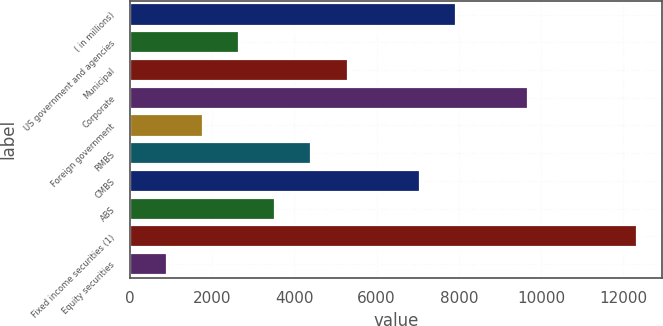<chart> <loc_0><loc_0><loc_500><loc_500><bar_chart><fcel>( in millions)<fcel>US government and agencies<fcel>Municipal<fcel>Corporate<fcel>Foreign government<fcel>RMBS<fcel>CMBS<fcel>ABS<fcel>Fixed income securities (1)<fcel>Equity securities<nl><fcel>7933.7<fcel>2651.9<fcel>5292.8<fcel>9694.3<fcel>1771.6<fcel>4412.5<fcel>7053.4<fcel>3532.2<fcel>12335.2<fcel>891.3<nl></chart> 